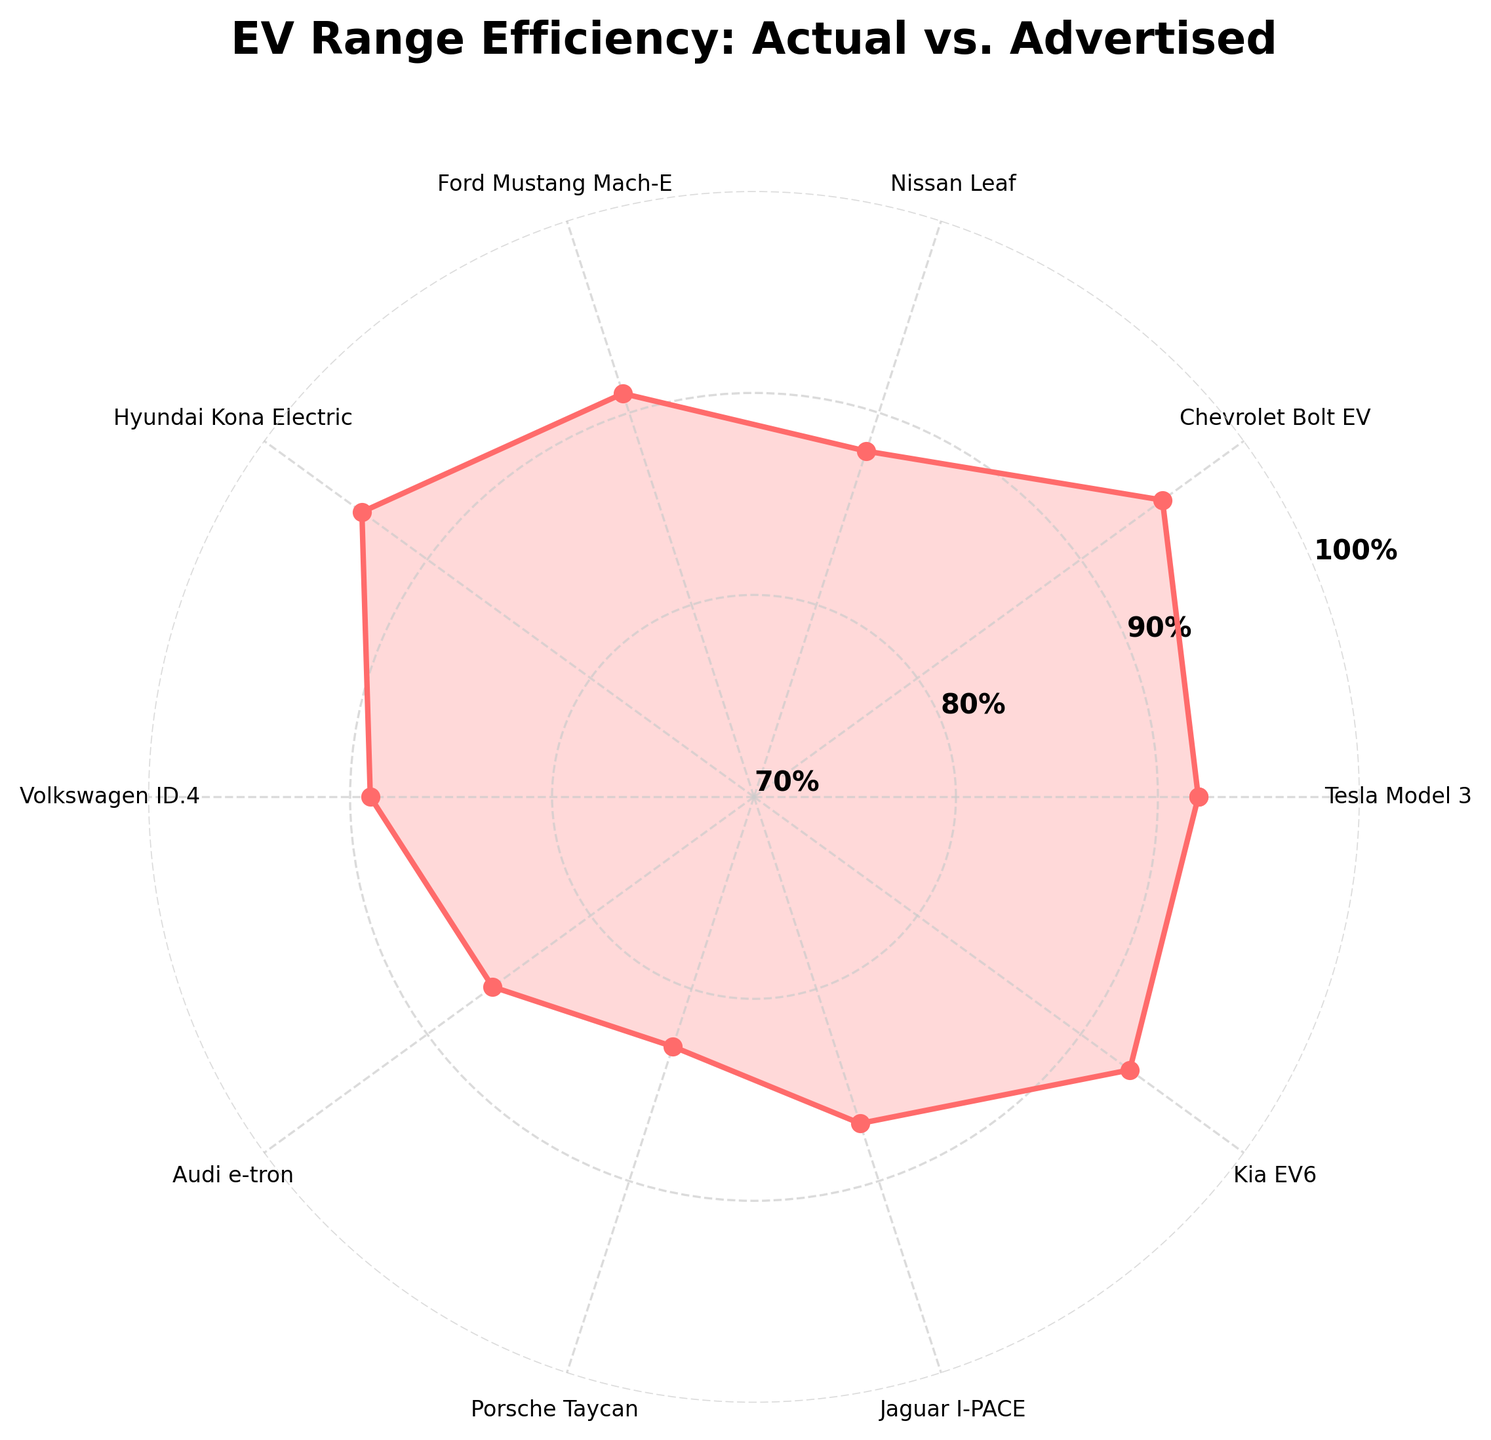What's the title of the chart? The title is located at the top of the figure and provides a summary of the chart's content. The title is "EV Range Efficiency: Actual vs. Advertised".
Answer: EV Range Efficiency: Actual vs. Advertised How many car models are compared in the chart? Each car model is represented by a labeled tick on the angular axis. Counting these labels will give the number of car models compared. There are 10 car models compared.
Answer: 10 What is the actual range percentage of the Porsche Taycan? Locate the label "Porsche Taycan" on the angular axis and look at the value corresponding to it. The value is 83%.
Answer: 83% Which car model has the highest actual range percentage? To answer this, locate the highest value on the radial axis and find the corresponding car model. The Chevrolet Bolt EV has the highest actual range percentage at 95%.
Answer: Chevrolet Bolt EV Which car model has the lowest actual range percentage? Similarly, locate the lowest value on the radial axis and find the corresponding car model. The Porsche Taycan has the lowest actual range percentage at 83%.
Answer: Porsche Taycan What's the difference in actual range percentage between the Hyundai Kona Electric and the Volkswagen ID.4? Find the actual range percentage for both car models. Hyundai Kona Electric is at 94%, and Volkswagen ID.4 is at 89%. Subtract the smaller percentage from the larger one: 94% - 89% = 5%.
Answer: 5% What is the average actual range percentage of all car models? Sum all the actual range percentage values and divide by the number of car models. Sum: 92+95+88+91+94+89+86+83+87+93 = 898. Number of models: 10. Average = 898/10 = 89.8%.
Answer: 89.8% How is the actual range of the Kia EV6 compared to the Tesla Model 3? Locate the values for both car models: Kia EV6 (93%), Tesla Model 3 (92%). Kia EV6 is 1% higher than the Tesla Model 3.
Answer: 1% higher Which two car models have an actual range percentage closest to each other? Compare the percentages to see the smallest difference. The closest values are Hyundai Kona Electric (94%) and Kia EV6 (93%), with a 1% difference.
Answer: Hyundai Kona Electric and Kia EV6 What colors are used to create the gauge-like appearance in the figure? The visual appearance of the gauge is created using three color wedges in a gradient. The colors are shades of red to green.
Answer: Shades of red to green 